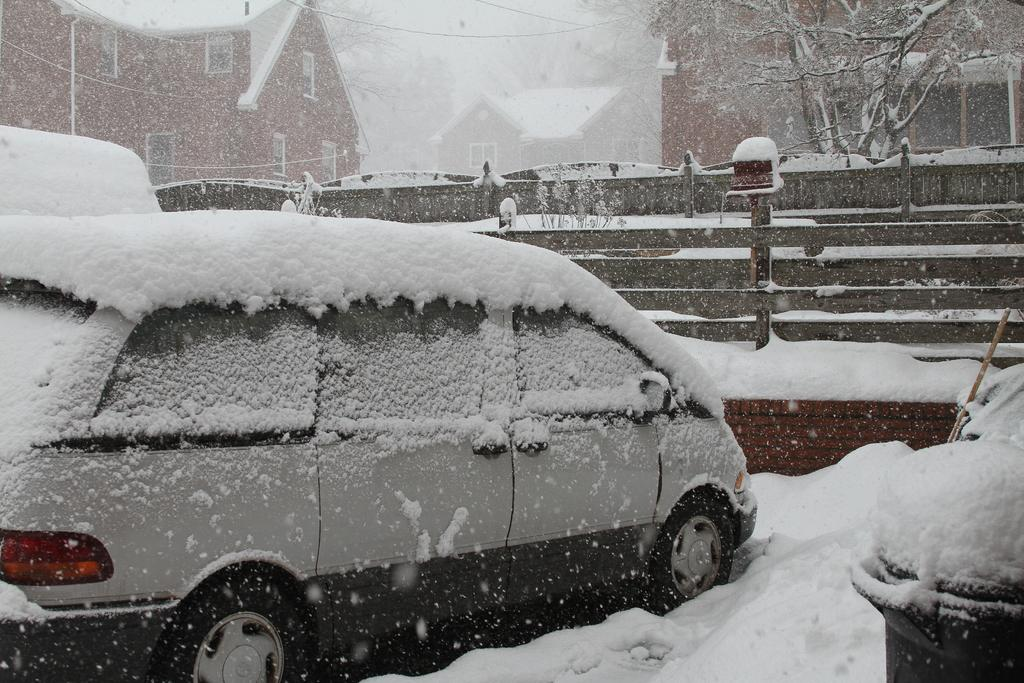What can be seen in the image that is used for transportation? There are vehicles in the image that are used for transportation. How is the snow affecting the vehicles in the image? The vehicles are covered with snow in the image. What is present in the image that separates different areas? There is a fence in the image that separates different areas. How is the snow affecting the fence in the image? The fence is covered with snow in the image. What other objects can be seen in the image besides vehicles and the fence? There are other objects in the image that are covered with snow. What can be seen in the background of the image? There are buildings and trees in the background of the image, both of which are covered with snow. How many sisters are visible in the image? There are no sisters present in the image. What type of wrist support is being used by the vehicles in the image? There is no wrist support present in the image, as it features vehicles and a snow-covered environment. 